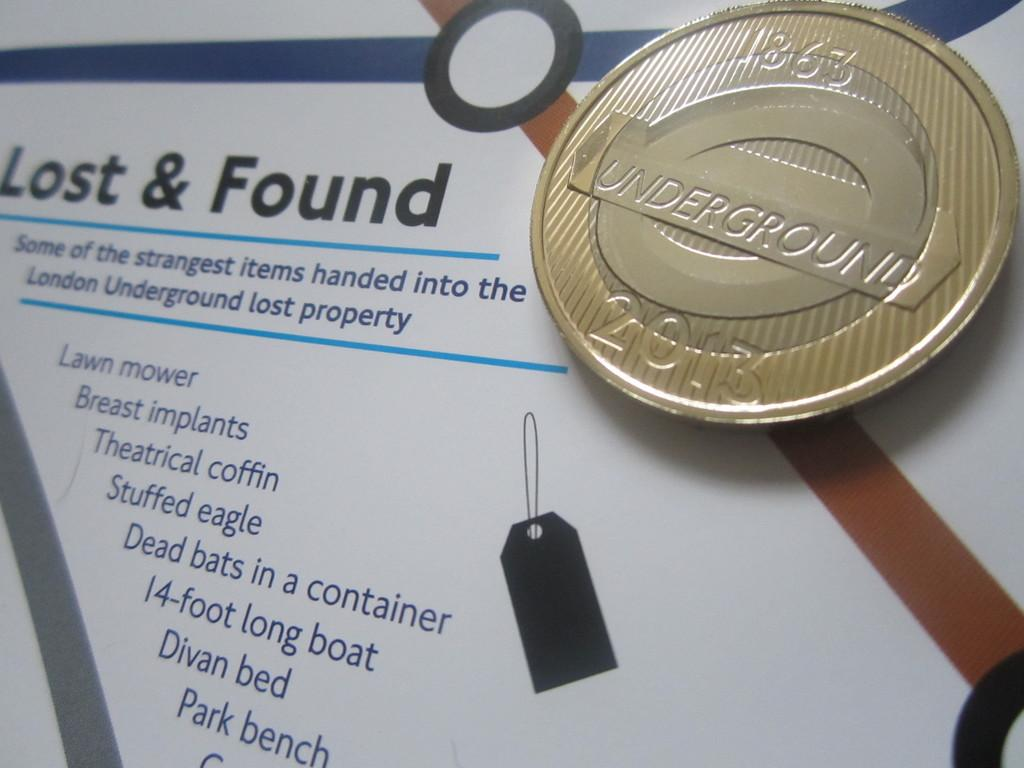Provide a one-sentence caption for the provided image. A piece of paper that says Lost & Found with various information it and a coin on top that says Underground 2013 on it. 